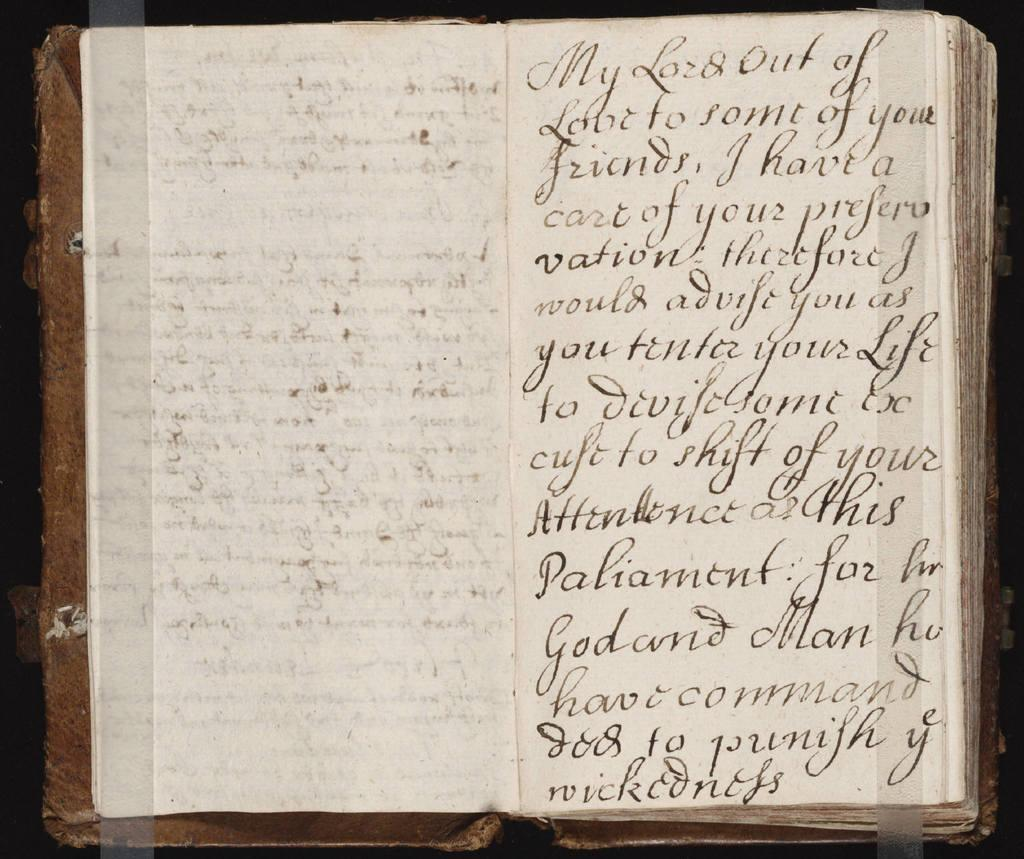What is present in the image related to reading material? There is a book in the image. What is the state of the book in the image? The book is opened. Can you describe what can be seen inside the book? There is text visible in the book. What type of invention is being demonstrated in the image? There is no invention being demonstrated in the image; it only features a book that is opened and has visible text. 